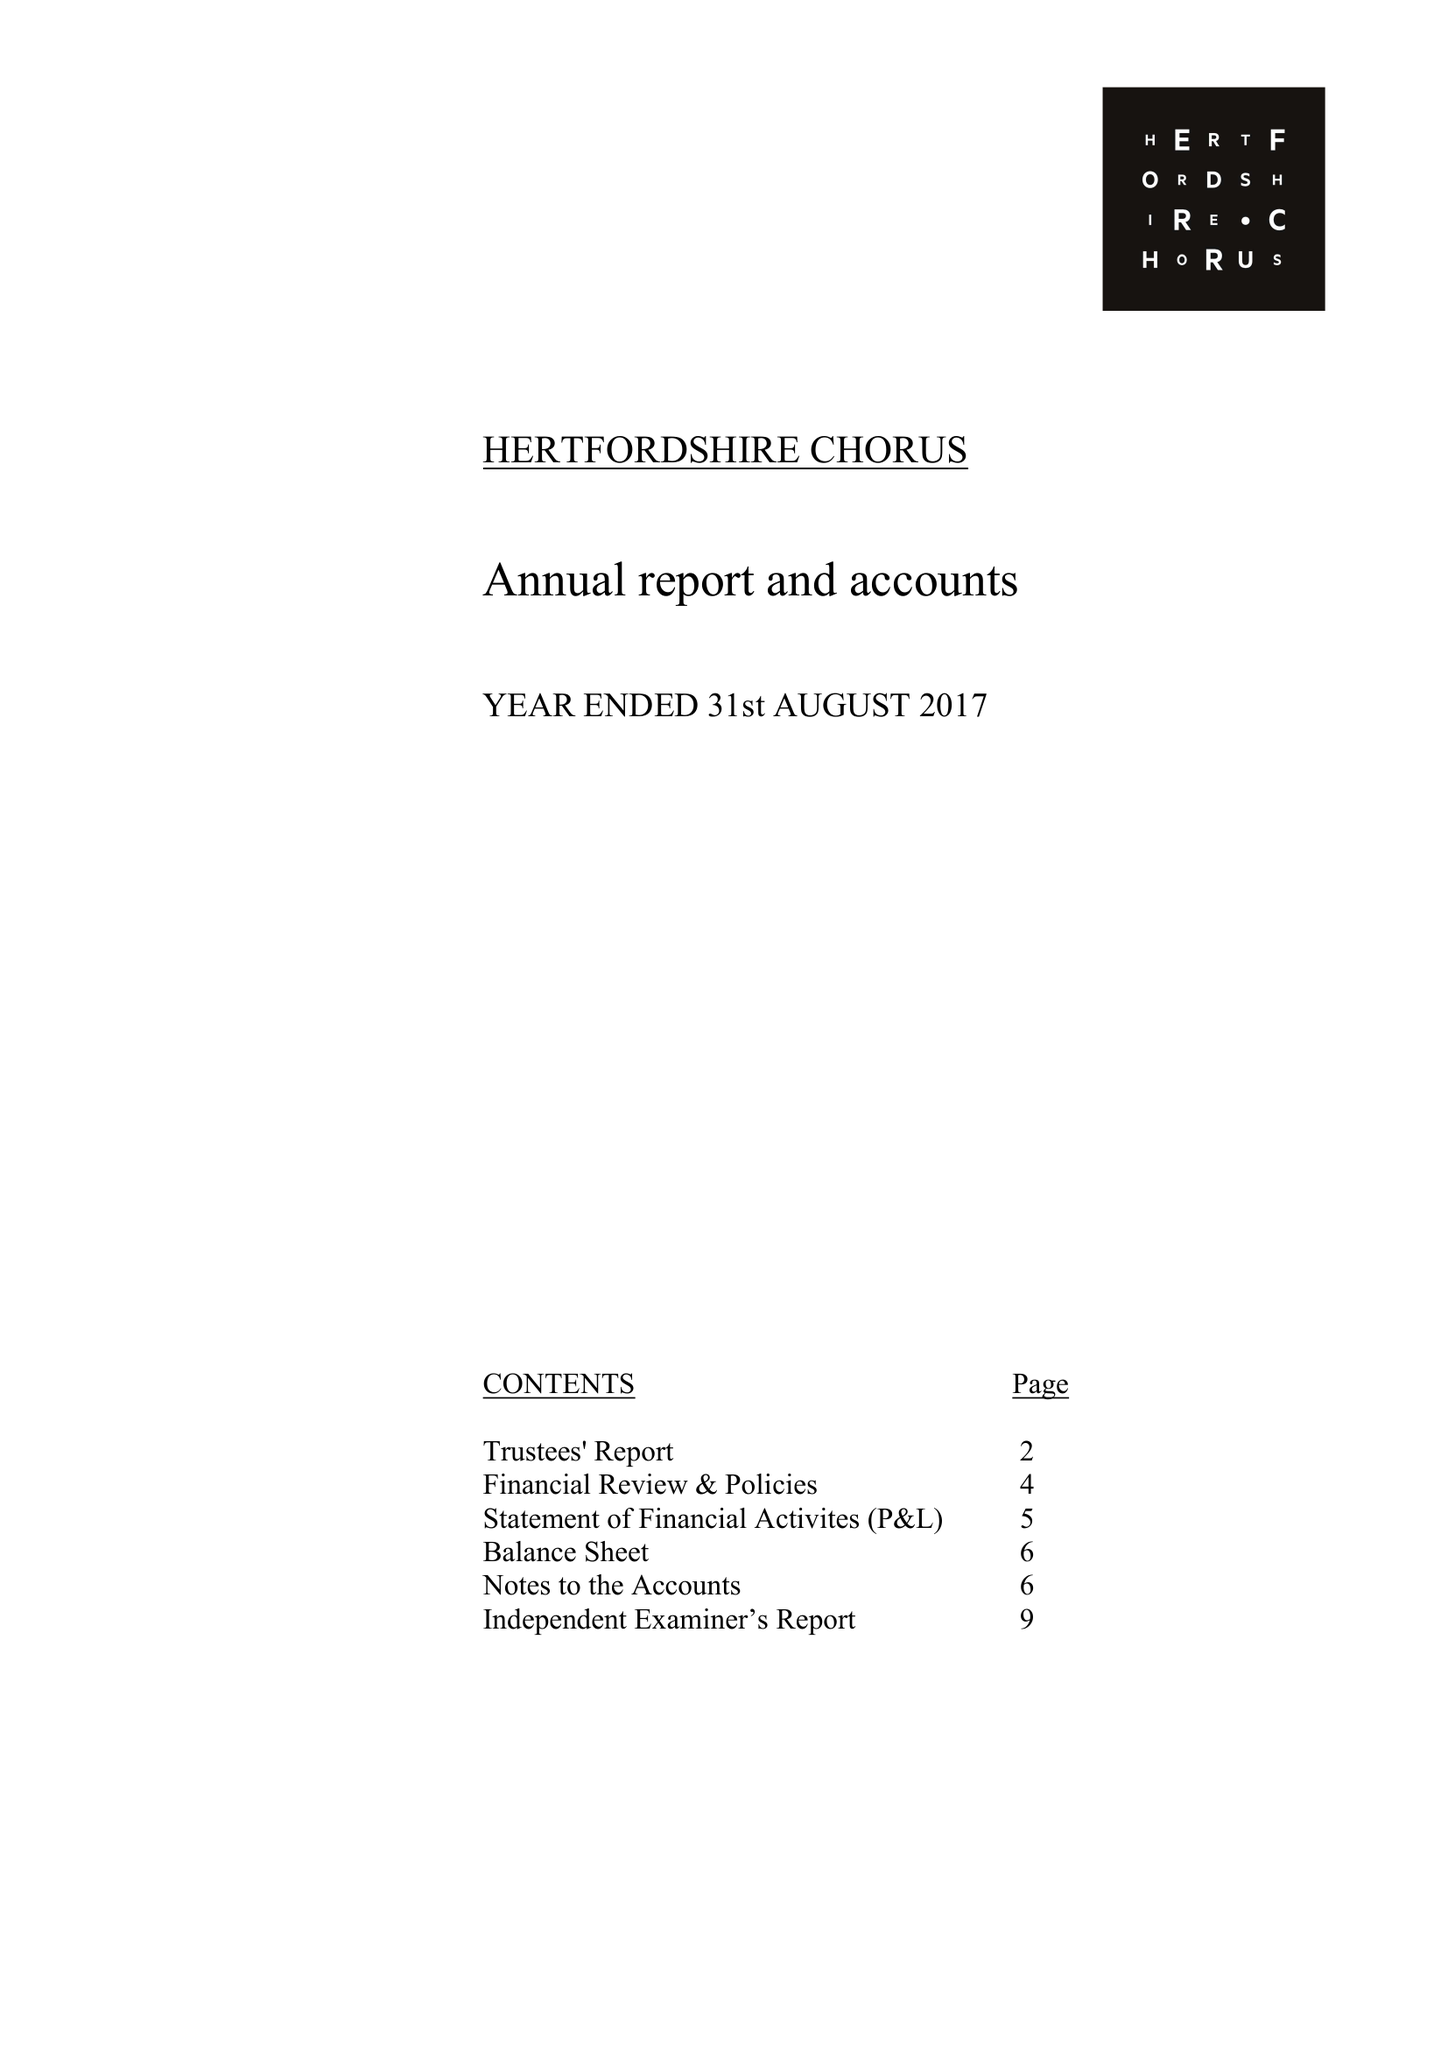What is the value for the charity_number?
Answer the question using a single word or phrase. 281627 